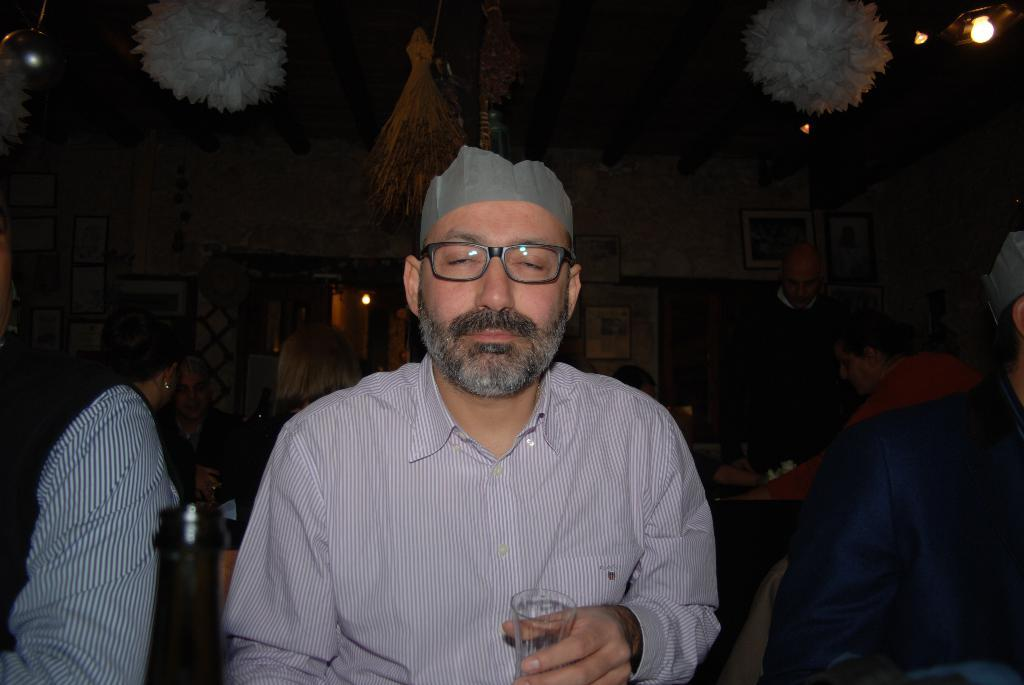What is the person in the image holding? The person is holding a glass in the image. What can be seen in the background of the image? There is a group of persons, light, frames attached to the wall, and paper decorative items in the background of the image. How many people are in the background of the image? There is a group of persons in the background, but the exact number cannot be determined from the provided facts. What type of decorative items are present in the background of the image? The decorative items in the background are made of paper. What type of metal is visible in the image? There is no metal visible in the image. Can you describe the fear experienced by the person holding the glass in the image? There is no indication of fear experienced by the person holding the glass in the image. 